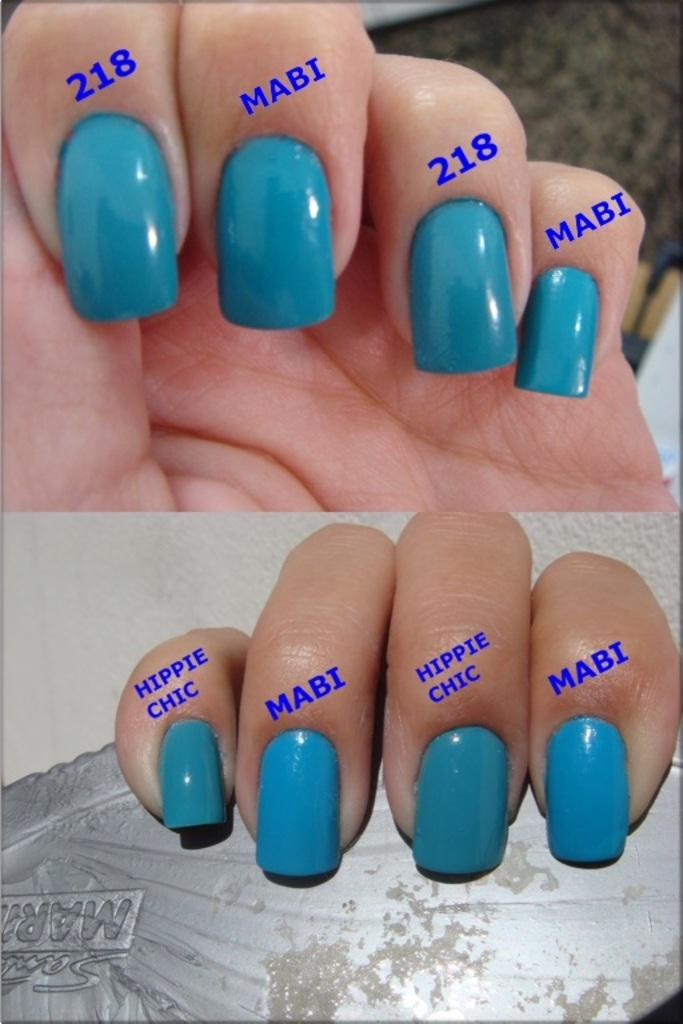Provide a one-sentence caption for the provided image. Fingernails with blue nail polish and various words above the nails including hippie chic, MABI, and 218. 